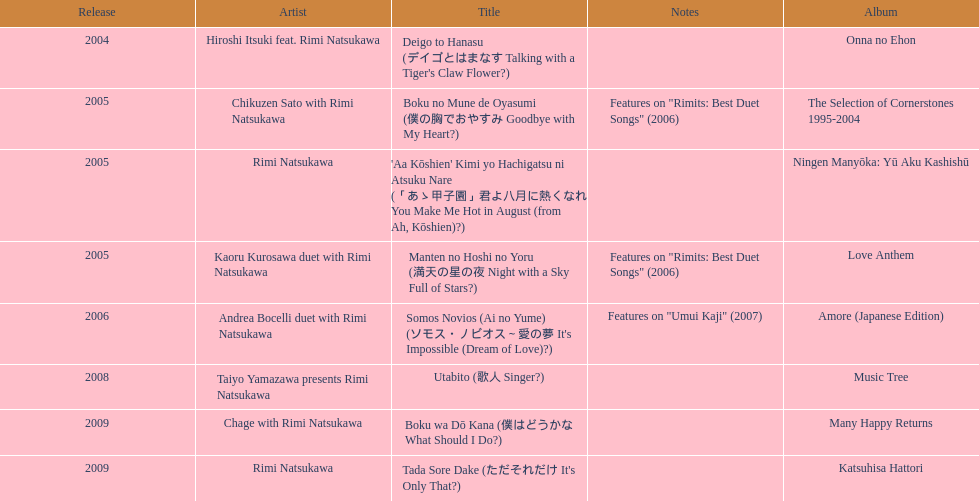What was the total number of appearances made by this artist in 2005, apart from this one? 3. 